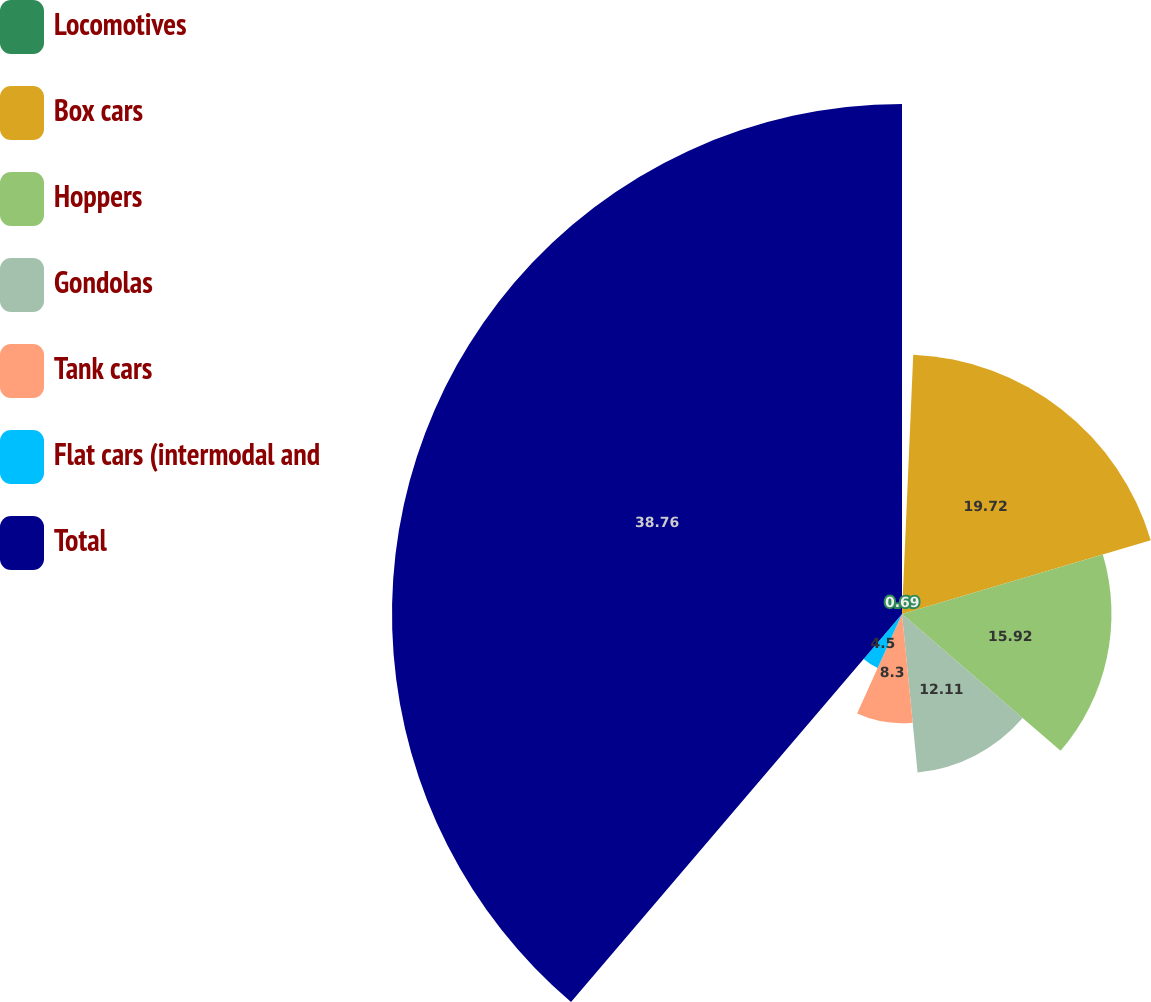<chart> <loc_0><loc_0><loc_500><loc_500><pie_chart><fcel>Locomotives<fcel>Box cars<fcel>Hoppers<fcel>Gondolas<fcel>Tank cars<fcel>Flat cars (intermodal and<fcel>Total<nl><fcel>0.69%<fcel>19.72%<fcel>15.92%<fcel>12.11%<fcel>8.3%<fcel>4.5%<fcel>38.76%<nl></chart> 